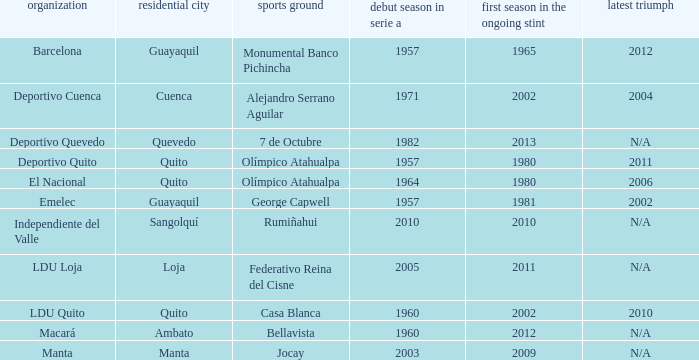Name the last title for 2012 N/A. 